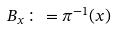Convert formula to latex. <formula><loc_0><loc_0><loc_500><loc_500>B _ { x } \colon = \pi ^ { - 1 } ( x )</formula> 